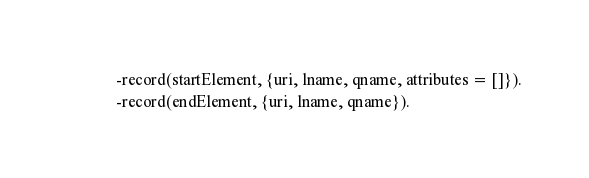Convert code to text. <code><loc_0><loc_0><loc_500><loc_500><_Erlang_>-record(startElement, {uri, lname, qname, attributes = []}).
-record(endElement, {uri, lname, qname}).
</code> 